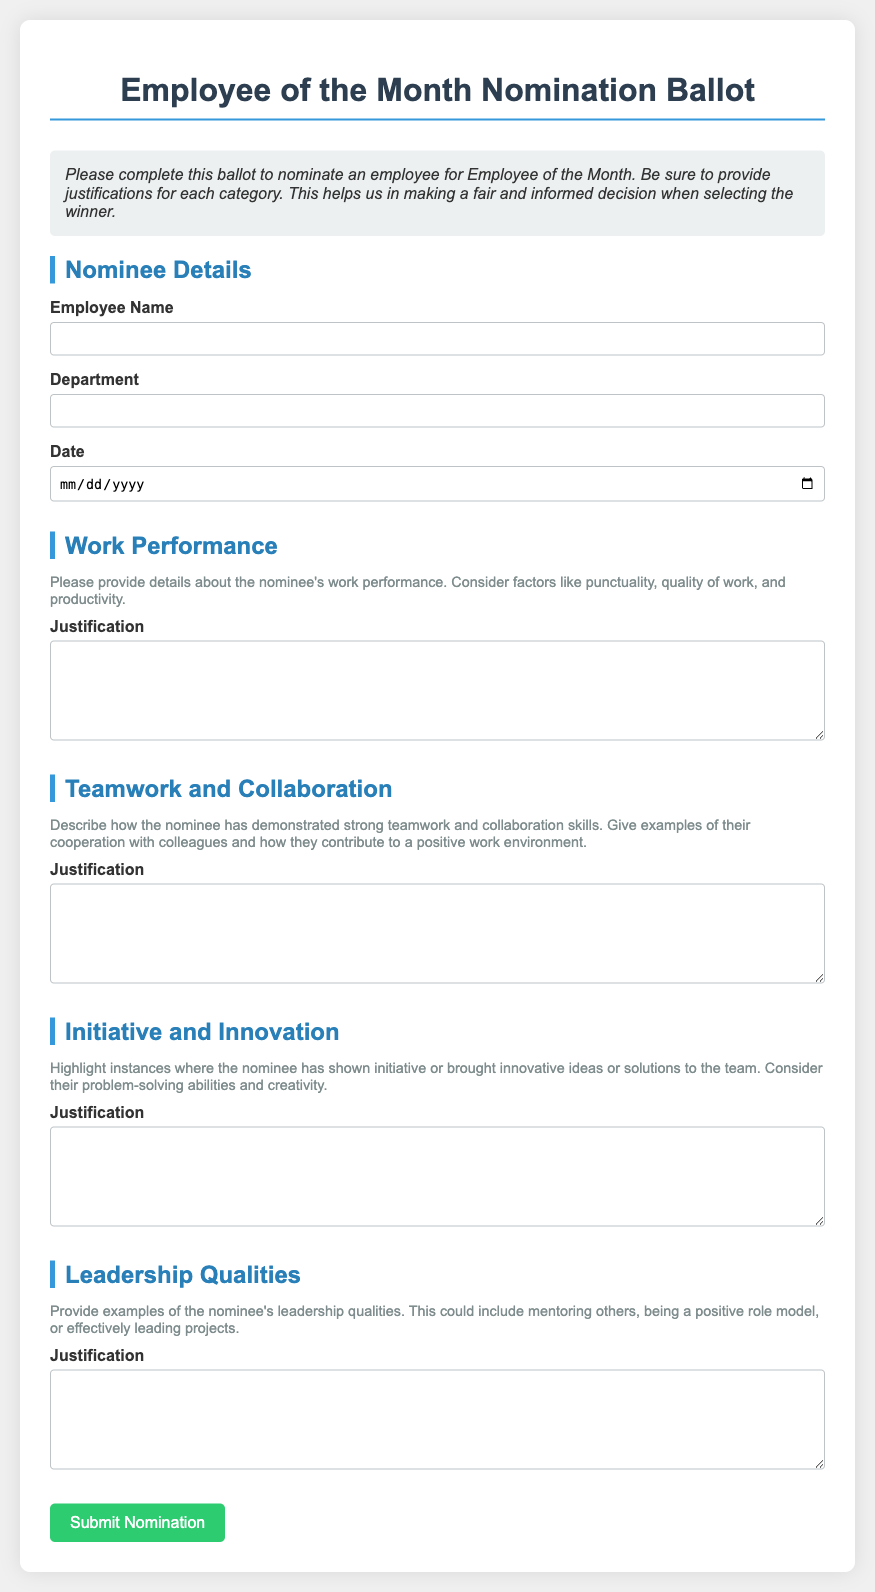What is the title of the document? The title of the document is mentioned at the top of the rendered page.
Answer: Employee of the Month Nomination Ballot What is the maximum width of the container? The document mentions the maximum width for the container in the style settings.
Answer: 800px What should be included in the Work Performance justification? The document specifies factors that should be considered for the Work Performance section.
Answer: Punctuality, quality of work, productivity What color is the submit button? The style settings describe the color of the submit button.
Answer: Green What type of input is required for Employee Name? The document states the format required for the Employee Name input.
Answer: Text How many sections are there in total? The document lists different sections with titled headers for nominations.
Answer: Five What does the category description for Teamwork and Collaboration request? The document provides guidance on what to describe in the category for Teamwork.
Answer: Strong teamwork and collaboration skills What is the purpose of the justification fields? The document explains the reason behind providing justifications in the ballot.
Answer: To make a fair and informed decision What is the color of the section titles? The style settings specify the color for the section titles.
Answer: Blue 